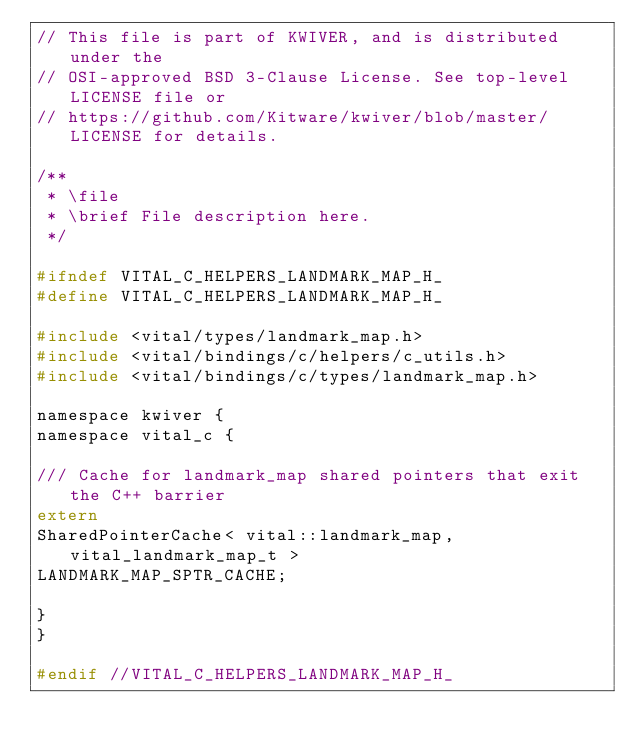<code> <loc_0><loc_0><loc_500><loc_500><_C_>// This file is part of KWIVER, and is distributed under the
// OSI-approved BSD 3-Clause License. See top-level LICENSE file or
// https://github.com/Kitware/kwiver/blob/master/LICENSE for details.

/**
 * \file
 * \brief File description here.
 */

#ifndef VITAL_C_HELPERS_LANDMARK_MAP_H_
#define VITAL_C_HELPERS_LANDMARK_MAP_H_

#include <vital/types/landmark_map.h>
#include <vital/bindings/c/helpers/c_utils.h>
#include <vital/bindings/c/types/landmark_map.h>

namespace kwiver {
namespace vital_c {

/// Cache for landmark_map shared pointers that exit the C++ barrier
extern
SharedPointerCache< vital::landmark_map, vital_landmark_map_t >
LANDMARK_MAP_SPTR_CACHE;

}
}

#endif //VITAL_C_HELPERS_LANDMARK_MAP_H_
</code> 